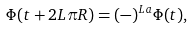Convert formula to latex. <formula><loc_0><loc_0><loc_500><loc_500>\Phi ( t + 2 L \pi R ) = ( - ) ^ { L a } \Phi ( t ) ,</formula> 